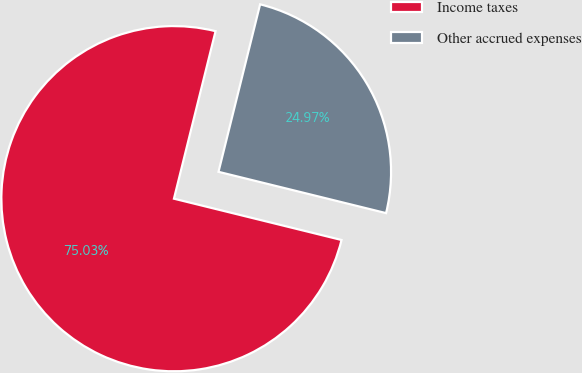Convert chart to OTSL. <chart><loc_0><loc_0><loc_500><loc_500><pie_chart><fcel>Income taxes<fcel>Other accrued expenses<nl><fcel>75.03%<fcel>24.97%<nl></chart> 